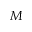<formula> <loc_0><loc_0><loc_500><loc_500>M</formula> 